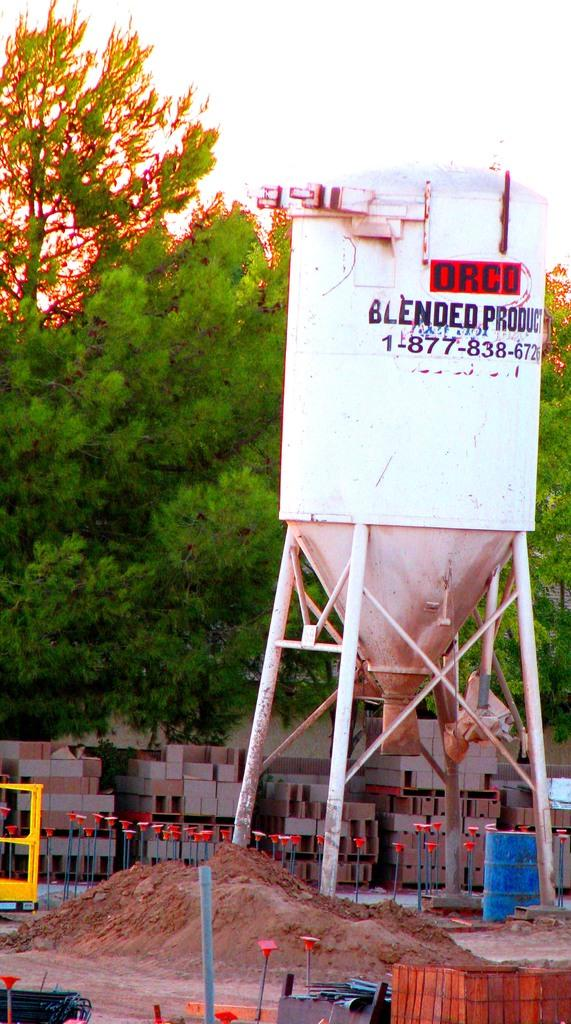What is the main object in the image? There is a machine in the image. What color is the machine? The machine is white in color. What can be seen in the background of the image? There are trees in the background of the image. What color are the trees? The trees are green in color. What other objects are visible in the image? There are blocks visible in the image. What color is the sky in the image? The sky is white in color. How many clocks are hanging on the machine in the image? There are no clocks visible on the machine in the image. What type of texture can be seen on the blocks in the image? The provided facts do not mention the texture of the blocks, so we cannot determine their texture from the image. 